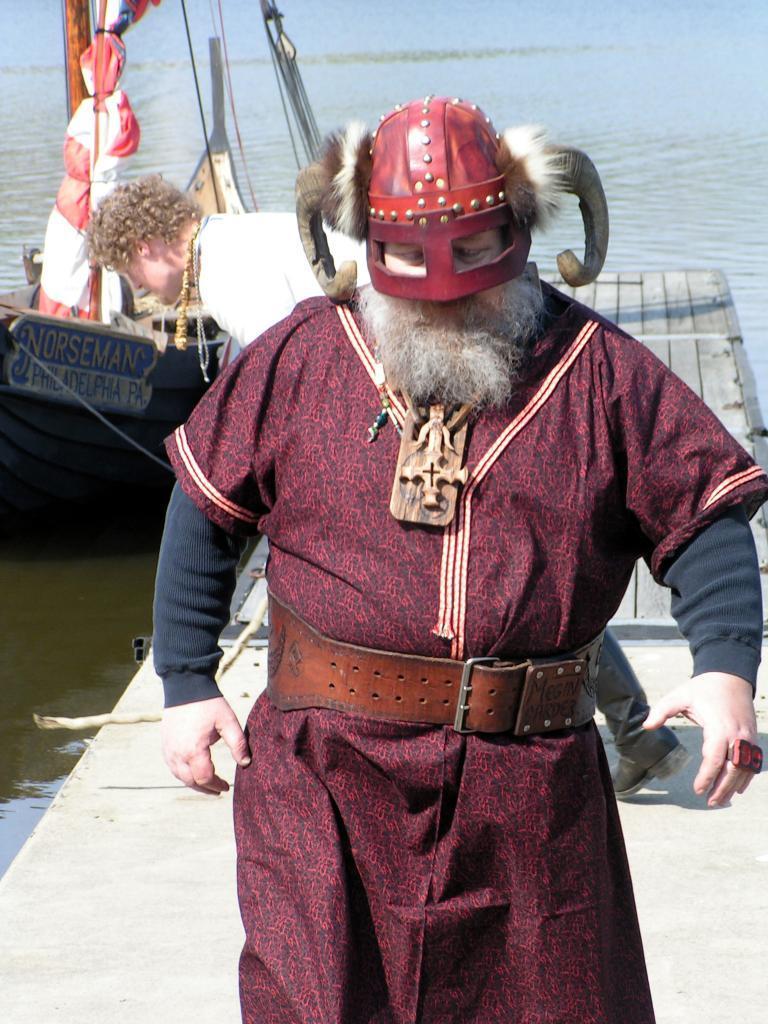Please provide a concise description of this image. In this picture I can see a man in front who is wearing costume and a helmet and behind him I can see another man and they're on the path. In the background I can see a boat and it is on the water and I can also see few wires. 